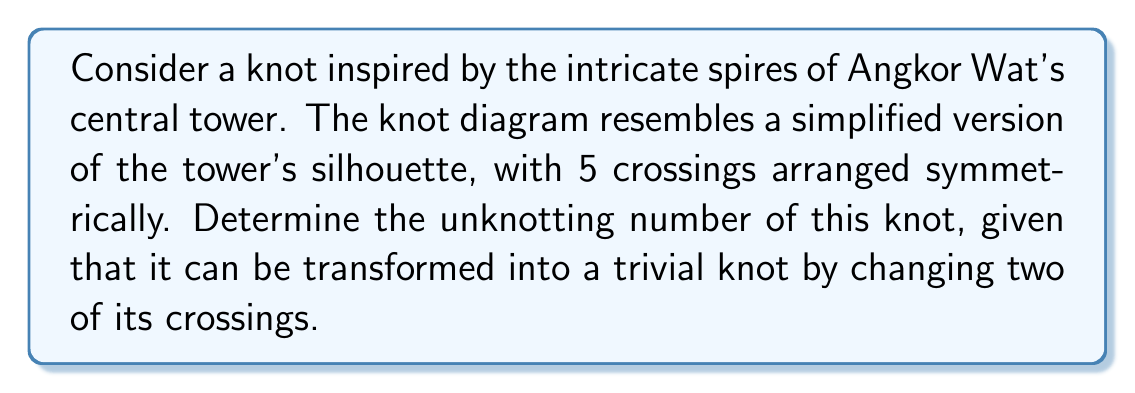Can you solve this math problem? Let's approach this step-by-step:

1) First, recall that the unknotting number of a knot is the minimum number of crossing changes required to transform the knot into the unknot (trivial knot).

2) We are given that the knot can be transformed into a trivial knot by changing two of its crossings. This means that the unknotting number is at most 2.

3) To prove that the unknotting number is exactly 2, we need to show that it's impossible to unknot it with just one crossing change.

4) Consider the knot's crossing number, which is 5 in this case. A well-known theorem in knot theory states that:

   $$u(K) \leq \frac{c(K)}{2}$$

   where $u(K)$ is the unknotting number and $c(K)$ is the crossing number of the knot $K$.

5) In our case, $c(K) = 5$, so:

   $$u(K) \leq \frac{5}{2} = 2.5$$

6) Since the unknotting number must be an integer, this implies $u(K) \leq 2$.

7) We're given that two crossing changes can unknot it, and we've shown it can't be more than 2. Therefore, the unknotting number must be exactly 2.

8) This result aligns with the symmetry of Angkor Wat's architecture, where balance and duality are important principles.
Answer: 2 